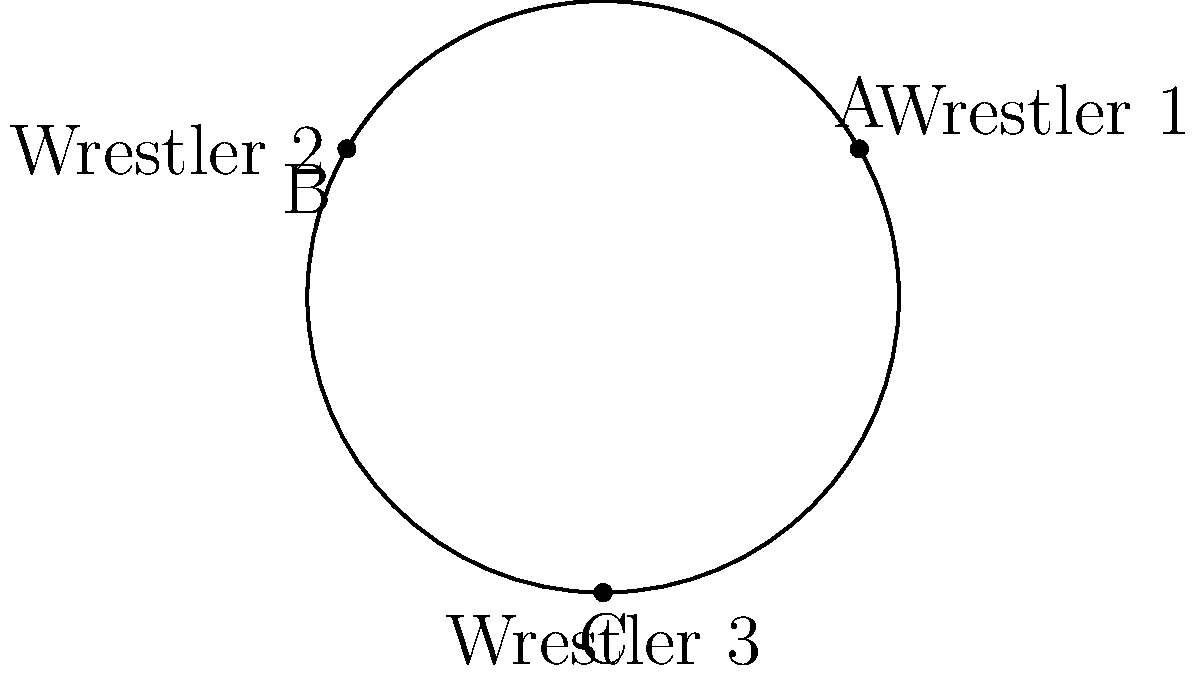Three wrestlers are positioned on a spherical wrestling ring, forming a triangle ABC as shown in the figure. Given that the sum of the interior angles of this spherical triangle is 270°, what is the area of the triangle in terms of the radius (R) of the sphere? To solve this problem, we'll use concepts from non-Euclidean geometry, specifically spherical geometry:

1. In spherical geometry, the sum of angles in a triangle is always greater than 180°. The excess over 180° is directly related to the area of the triangle.

2. Let E be the excess: E = (sum of angles) - 180°
   In this case, E = 270° - 180° = 90° = $\frac{\pi}{2}$ radians

3. The area of a spherical triangle is given by the formula:
   Area = $E R^2$, where R is the radius of the sphere

4. Substituting our excess:
   Area = $\frac{\pi}{2} R^2$

5. This can be simplified to:
   Area = $\frac{1}{2} \pi R^2$

This result shows that the area of the spherical triangle formed by the three wrestlers is half the area of a great circle on the sphere.
Answer: $\frac{1}{2} \pi R^2$ 